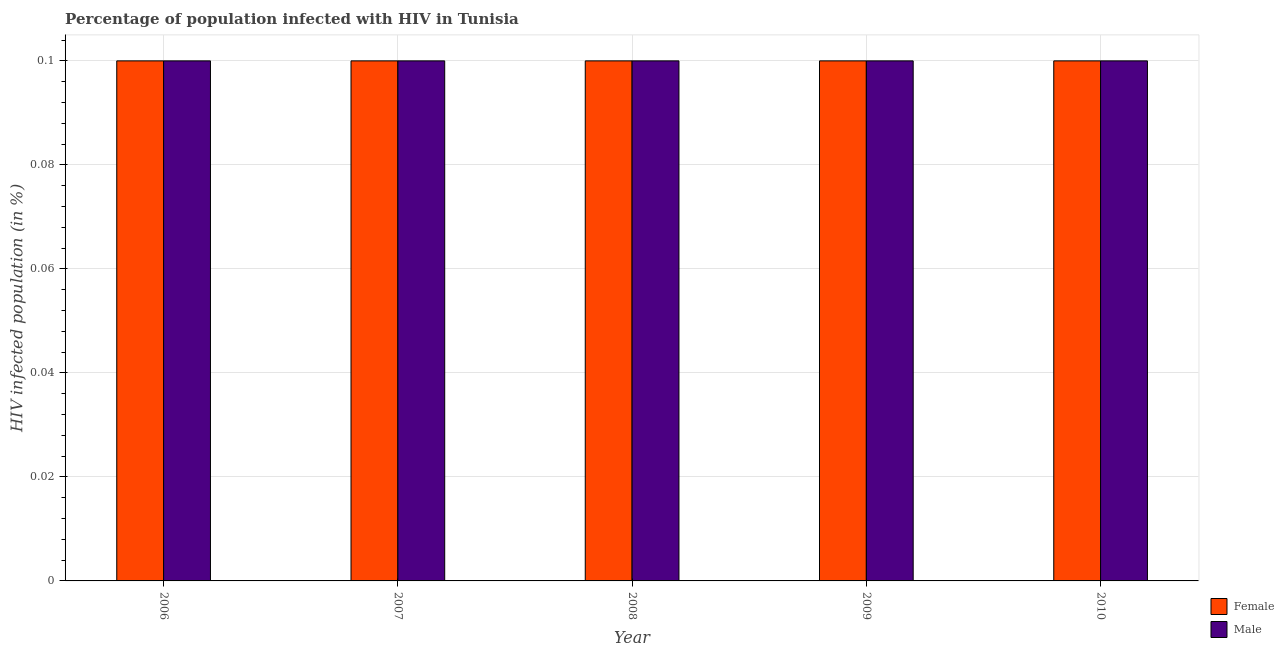How many bars are there on the 1st tick from the left?
Your answer should be compact. 2. How many bars are there on the 2nd tick from the right?
Provide a short and direct response. 2. In how many cases, is the number of bars for a given year not equal to the number of legend labels?
Your answer should be compact. 0. What is the percentage of males who are infected with hiv in 2010?
Offer a very short reply. 0.1. Across all years, what is the maximum percentage of males who are infected with hiv?
Keep it short and to the point. 0.1. What is the difference between the percentage of females who are infected with hiv in 2006 and that in 2008?
Your response must be concise. 0. What is the difference between the percentage of females who are infected with hiv in 2008 and the percentage of males who are infected with hiv in 2010?
Make the answer very short. 0. What is the average percentage of females who are infected with hiv per year?
Provide a succinct answer. 0.1. In how many years, is the percentage of females who are infected with hiv greater than 0.08 %?
Provide a succinct answer. 5. Is the percentage of males who are infected with hiv in 2007 less than that in 2008?
Ensure brevity in your answer.  No. What is the difference between the highest and the second highest percentage of females who are infected with hiv?
Give a very brief answer. 0. Does the graph contain any zero values?
Offer a very short reply. No. Where does the legend appear in the graph?
Provide a succinct answer. Bottom right. How many legend labels are there?
Your answer should be compact. 2. What is the title of the graph?
Provide a short and direct response. Percentage of population infected with HIV in Tunisia. Does "Boys" appear as one of the legend labels in the graph?
Provide a succinct answer. No. What is the label or title of the X-axis?
Provide a short and direct response. Year. What is the label or title of the Y-axis?
Your response must be concise. HIV infected population (in %). What is the HIV infected population (in %) of Female in 2006?
Provide a succinct answer. 0.1. What is the HIV infected population (in %) in Male in 2007?
Provide a succinct answer. 0.1. What is the HIV infected population (in %) in Female in 2009?
Ensure brevity in your answer.  0.1. What is the HIV infected population (in %) of Male in 2009?
Your answer should be very brief. 0.1. Across all years, what is the maximum HIV infected population (in %) of Female?
Your answer should be very brief. 0.1. Across all years, what is the minimum HIV infected population (in %) of Male?
Your response must be concise. 0.1. What is the total HIV infected population (in %) in Female in the graph?
Give a very brief answer. 0.5. What is the total HIV infected population (in %) of Male in the graph?
Your answer should be very brief. 0.5. What is the difference between the HIV infected population (in %) of Male in 2006 and that in 2007?
Your answer should be compact. 0. What is the difference between the HIV infected population (in %) of Female in 2006 and that in 2008?
Keep it short and to the point. 0. What is the difference between the HIV infected population (in %) in Male in 2006 and that in 2008?
Give a very brief answer. 0. What is the difference between the HIV infected population (in %) of Male in 2006 and that in 2010?
Your answer should be compact. 0. What is the difference between the HIV infected population (in %) of Female in 2007 and that in 2009?
Provide a short and direct response. 0. What is the difference between the HIV infected population (in %) of Male in 2007 and that in 2009?
Keep it short and to the point. 0. What is the difference between the HIV infected population (in %) in Female in 2007 and that in 2010?
Give a very brief answer. 0. What is the difference between the HIV infected population (in %) in Male in 2007 and that in 2010?
Give a very brief answer. 0. What is the difference between the HIV infected population (in %) in Female in 2008 and that in 2009?
Give a very brief answer. 0. What is the difference between the HIV infected population (in %) of Male in 2008 and that in 2009?
Offer a terse response. 0. What is the difference between the HIV infected population (in %) of Female in 2008 and that in 2010?
Ensure brevity in your answer.  0. What is the difference between the HIV infected population (in %) in Female in 2006 and the HIV infected population (in %) in Male in 2008?
Provide a short and direct response. 0. What is the difference between the HIV infected population (in %) of Female in 2006 and the HIV infected population (in %) of Male in 2009?
Make the answer very short. 0. What is the difference between the HIV infected population (in %) in Female in 2007 and the HIV infected population (in %) in Male in 2009?
Give a very brief answer. 0. What is the difference between the HIV infected population (in %) in Female in 2008 and the HIV infected population (in %) in Male in 2010?
Make the answer very short. 0. What is the average HIV infected population (in %) of Female per year?
Keep it short and to the point. 0.1. What is the average HIV infected population (in %) in Male per year?
Your answer should be very brief. 0.1. In the year 2006, what is the difference between the HIV infected population (in %) of Female and HIV infected population (in %) of Male?
Your answer should be compact. 0. In the year 2009, what is the difference between the HIV infected population (in %) of Female and HIV infected population (in %) of Male?
Your answer should be compact. 0. What is the ratio of the HIV infected population (in %) of Female in 2006 to that in 2009?
Keep it short and to the point. 1. What is the ratio of the HIV infected population (in %) in Female in 2006 to that in 2010?
Your answer should be compact. 1. What is the ratio of the HIV infected population (in %) of Male in 2006 to that in 2010?
Your answer should be compact. 1. What is the ratio of the HIV infected population (in %) of Female in 2007 to that in 2008?
Provide a succinct answer. 1. What is the ratio of the HIV infected population (in %) in Female in 2007 to that in 2009?
Your answer should be compact. 1. What is the ratio of the HIV infected population (in %) of Male in 2007 to that in 2009?
Ensure brevity in your answer.  1. What is the ratio of the HIV infected population (in %) of Female in 2009 to that in 2010?
Your response must be concise. 1. What is the ratio of the HIV infected population (in %) in Male in 2009 to that in 2010?
Offer a very short reply. 1. What is the difference between the highest and the second highest HIV infected population (in %) in Female?
Offer a very short reply. 0. What is the difference between the highest and the lowest HIV infected population (in %) of Female?
Make the answer very short. 0. What is the difference between the highest and the lowest HIV infected population (in %) in Male?
Offer a terse response. 0. 